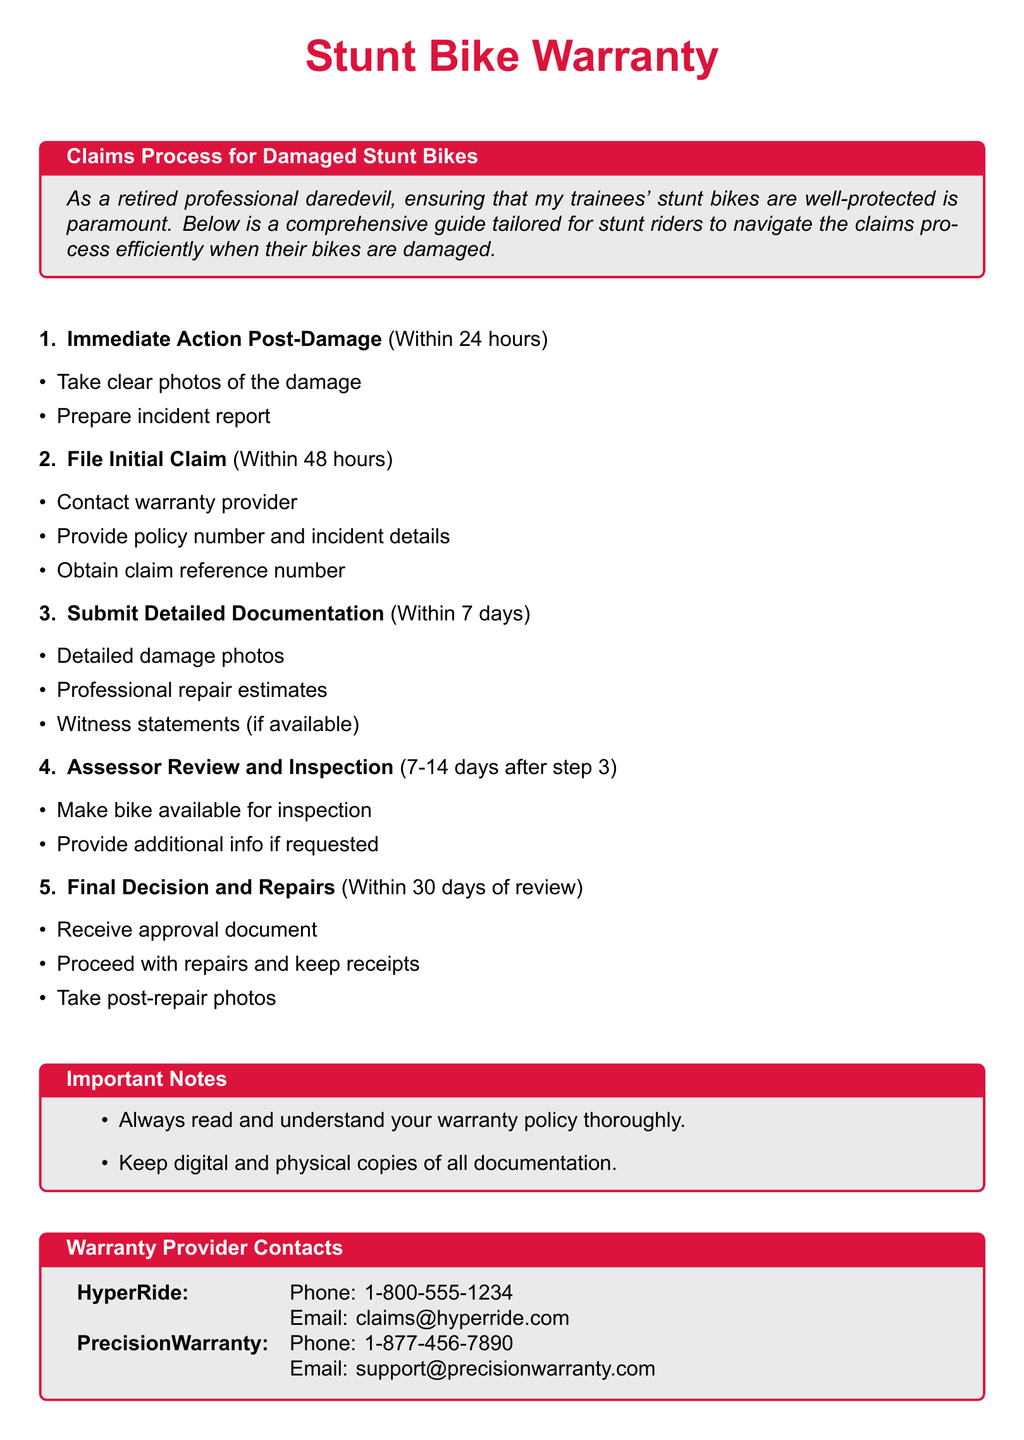What is the first step post-damage? The first step post-damage is to take clear photos of the damage and prepare an incident report.
Answer: Take clear photos and prepare incident report What is the timeline for filing the initial claim? The initial claim must be filed within 48 hours of the incident.
Answer: Within 48 hours How many days do you have to submit detailed documentation? Detailed documentation must be submitted within 7 days after filing the initial claim.
Answer: Within 7 days What is the time frame for the assessor review and inspection? The assessor review and inspection occur within 7-14 days after submitting detailed documentation.
Answer: 7-14 days What must you keep after repairs? After repairs, you must keep receipts and take post-repair photos.
Answer: Keep receipts and take post-repair photos What should you do if additional information is requested during the inspection? If additional information is requested, you should provide it as needed.
Answer: Provide additional info What is the final decision timeline? The final decision is made within 30 days of the review and inspection.
Answer: Within 30 days What are the warranty provider contacts for HyperRide? For HyperRide, the contact is Phone: 1-800-555-1234 and Email: claims@hyperride.com.
Answer: Phone: 1-800-555-1234; Email: claims@hyperride.com What type of warranty documentation should you keep? You should keep digital and physical copies of all documentation.
Answer: Digital and physical copies 